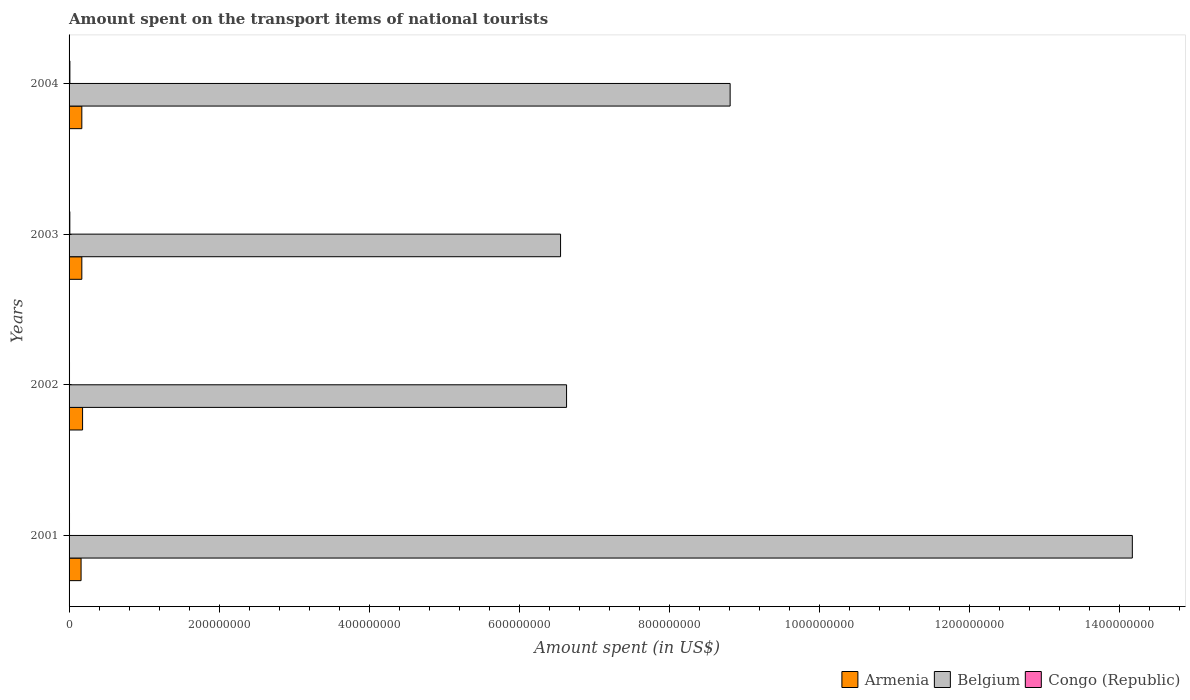How many groups of bars are there?
Your response must be concise. 4. How many bars are there on the 3rd tick from the bottom?
Ensure brevity in your answer.  3. In how many cases, is the number of bars for a given year not equal to the number of legend labels?
Offer a very short reply. 0. What is the amount spent on the transport items of national tourists in Belgium in 2003?
Give a very brief answer. 6.55e+08. Across all years, what is the maximum amount spent on the transport items of national tourists in Congo (Republic)?
Keep it short and to the point. 1.10e+06. What is the total amount spent on the transport items of national tourists in Congo (Republic) in the graph?
Provide a short and direct response. 3.30e+06. What is the difference between the amount spent on the transport items of national tourists in Belgium in 2004 and the amount spent on the transport items of national tourists in Armenia in 2002?
Your answer should be compact. 8.63e+08. What is the average amount spent on the transport items of national tourists in Belgium per year?
Offer a very short reply. 9.04e+08. In the year 2004, what is the difference between the amount spent on the transport items of national tourists in Congo (Republic) and amount spent on the transport items of national tourists in Belgium?
Provide a short and direct response. -8.80e+08. What is the ratio of the amount spent on the transport items of national tourists in Belgium in 2001 to that in 2003?
Make the answer very short. 2.16. Is the difference between the amount spent on the transport items of national tourists in Congo (Republic) in 2001 and 2003 greater than the difference between the amount spent on the transport items of national tourists in Belgium in 2001 and 2003?
Provide a short and direct response. No. What is the difference between the highest and the second highest amount spent on the transport items of national tourists in Belgium?
Your answer should be compact. 5.36e+08. What is the difference between the highest and the lowest amount spent on the transport items of national tourists in Belgium?
Make the answer very short. 7.62e+08. What does the 2nd bar from the top in 2003 represents?
Your response must be concise. Belgium. What does the 1st bar from the bottom in 2002 represents?
Give a very brief answer. Armenia. How many bars are there?
Provide a short and direct response. 12. Are all the bars in the graph horizontal?
Keep it short and to the point. Yes. Are the values on the major ticks of X-axis written in scientific E-notation?
Your answer should be very brief. No. Where does the legend appear in the graph?
Provide a succinct answer. Bottom right. What is the title of the graph?
Ensure brevity in your answer.  Amount spent on the transport items of national tourists. Does "Syrian Arab Republic" appear as one of the legend labels in the graph?
Provide a succinct answer. No. What is the label or title of the X-axis?
Your response must be concise. Amount spent (in US$). What is the Amount spent (in US$) of Armenia in 2001?
Provide a short and direct response. 1.60e+07. What is the Amount spent (in US$) in Belgium in 2001?
Offer a very short reply. 1.42e+09. What is the Amount spent (in US$) in Armenia in 2002?
Provide a short and direct response. 1.80e+07. What is the Amount spent (in US$) in Belgium in 2002?
Your answer should be compact. 6.63e+08. What is the Amount spent (in US$) of Armenia in 2003?
Offer a terse response. 1.70e+07. What is the Amount spent (in US$) in Belgium in 2003?
Your answer should be compact. 6.55e+08. What is the Amount spent (in US$) of Armenia in 2004?
Make the answer very short. 1.70e+07. What is the Amount spent (in US$) in Belgium in 2004?
Your response must be concise. 8.81e+08. What is the Amount spent (in US$) of Congo (Republic) in 2004?
Provide a succinct answer. 1.10e+06. Across all years, what is the maximum Amount spent (in US$) of Armenia?
Offer a very short reply. 1.80e+07. Across all years, what is the maximum Amount spent (in US$) of Belgium?
Your answer should be compact. 1.42e+09. Across all years, what is the maximum Amount spent (in US$) in Congo (Republic)?
Give a very brief answer. 1.10e+06. Across all years, what is the minimum Amount spent (in US$) of Armenia?
Give a very brief answer. 1.60e+07. Across all years, what is the minimum Amount spent (in US$) of Belgium?
Ensure brevity in your answer.  6.55e+08. Across all years, what is the minimum Amount spent (in US$) in Congo (Republic)?
Provide a succinct answer. 6.00e+05. What is the total Amount spent (in US$) in Armenia in the graph?
Give a very brief answer. 6.80e+07. What is the total Amount spent (in US$) in Belgium in the graph?
Provide a succinct answer. 3.62e+09. What is the total Amount spent (in US$) of Congo (Republic) in the graph?
Provide a short and direct response. 3.30e+06. What is the difference between the Amount spent (in US$) of Belgium in 2001 and that in 2002?
Offer a very short reply. 7.54e+08. What is the difference between the Amount spent (in US$) in Belgium in 2001 and that in 2003?
Your answer should be compact. 7.62e+08. What is the difference between the Amount spent (in US$) of Congo (Republic) in 2001 and that in 2003?
Ensure brevity in your answer.  -4.00e+05. What is the difference between the Amount spent (in US$) of Armenia in 2001 and that in 2004?
Provide a succinct answer. -1.00e+06. What is the difference between the Amount spent (in US$) of Belgium in 2001 and that in 2004?
Ensure brevity in your answer.  5.36e+08. What is the difference between the Amount spent (in US$) in Congo (Republic) in 2001 and that in 2004?
Your answer should be compact. -5.00e+05. What is the difference between the Amount spent (in US$) in Armenia in 2002 and that in 2003?
Offer a terse response. 1.00e+06. What is the difference between the Amount spent (in US$) in Belgium in 2002 and that in 2003?
Ensure brevity in your answer.  8.00e+06. What is the difference between the Amount spent (in US$) in Congo (Republic) in 2002 and that in 2003?
Your answer should be very brief. -4.00e+05. What is the difference between the Amount spent (in US$) of Belgium in 2002 and that in 2004?
Your answer should be compact. -2.18e+08. What is the difference between the Amount spent (in US$) in Congo (Republic) in 2002 and that in 2004?
Your answer should be very brief. -5.00e+05. What is the difference between the Amount spent (in US$) of Belgium in 2003 and that in 2004?
Your answer should be very brief. -2.26e+08. What is the difference between the Amount spent (in US$) of Congo (Republic) in 2003 and that in 2004?
Your answer should be compact. -1.00e+05. What is the difference between the Amount spent (in US$) in Armenia in 2001 and the Amount spent (in US$) in Belgium in 2002?
Keep it short and to the point. -6.47e+08. What is the difference between the Amount spent (in US$) of Armenia in 2001 and the Amount spent (in US$) of Congo (Republic) in 2002?
Ensure brevity in your answer.  1.54e+07. What is the difference between the Amount spent (in US$) in Belgium in 2001 and the Amount spent (in US$) in Congo (Republic) in 2002?
Offer a terse response. 1.42e+09. What is the difference between the Amount spent (in US$) in Armenia in 2001 and the Amount spent (in US$) in Belgium in 2003?
Your response must be concise. -6.39e+08. What is the difference between the Amount spent (in US$) in Armenia in 2001 and the Amount spent (in US$) in Congo (Republic) in 2003?
Ensure brevity in your answer.  1.50e+07. What is the difference between the Amount spent (in US$) of Belgium in 2001 and the Amount spent (in US$) of Congo (Republic) in 2003?
Offer a very short reply. 1.42e+09. What is the difference between the Amount spent (in US$) of Armenia in 2001 and the Amount spent (in US$) of Belgium in 2004?
Provide a succinct answer. -8.65e+08. What is the difference between the Amount spent (in US$) in Armenia in 2001 and the Amount spent (in US$) in Congo (Republic) in 2004?
Your response must be concise. 1.49e+07. What is the difference between the Amount spent (in US$) in Belgium in 2001 and the Amount spent (in US$) in Congo (Republic) in 2004?
Make the answer very short. 1.42e+09. What is the difference between the Amount spent (in US$) in Armenia in 2002 and the Amount spent (in US$) in Belgium in 2003?
Make the answer very short. -6.37e+08. What is the difference between the Amount spent (in US$) in Armenia in 2002 and the Amount spent (in US$) in Congo (Republic) in 2003?
Ensure brevity in your answer.  1.70e+07. What is the difference between the Amount spent (in US$) in Belgium in 2002 and the Amount spent (in US$) in Congo (Republic) in 2003?
Your answer should be compact. 6.62e+08. What is the difference between the Amount spent (in US$) of Armenia in 2002 and the Amount spent (in US$) of Belgium in 2004?
Provide a short and direct response. -8.63e+08. What is the difference between the Amount spent (in US$) of Armenia in 2002 and the Amount spent (in US$) of Congo (Republic) in 2004?
Provide a succinct answer. 1.69e+07. What is the difference between the Amount spent (in US$) of Belgium in 2002 and the Amount spent (in US$) of Congo (Republic) in 2004?
Make the answer very short. 6.62e+08. What is the difference between the Amount spent (in US$) of Armenia in 2003 and the Amount spent (in US$) of Belgium in 2004?
Your answer should be very brief. -8.64e+08. What is the difference between the Amount spent (in US$) of Armenia in 2003 and the Amount spent (in US$) of Congo (Republic) in 2004?
Keep it short and to the point. 1.59e+07. What is the difference between the Amount spent (in US$) of Belgium in 2003 and the Amount spent (in US$) of Congo (Republic) in 2004?
Give a very brief answer. 6.54e+08. What is the average Amount spent (in US$) of Armenia per year?
Your response must be concise. 1.70e+07. What is the average Amount spent (in US$) of Belgium per year?
Make the answer very short. 9.04e+08. What is the average Amount spent (in US$) of Congo (Republic) per year?
Offer a very short reply. 8.25e+05. In the year 2001, what is the difference between the Amount spent (in US$) of Armenia and Amount spent (in US$) of Belgium?
Your answer should be compact. -1.40e+09. In the year 2001, what is the difference between the Amount spent (in US$) of Armenia and Amount spent (in US$) of Congo (Republic)?
Ensure brevity in your answer.  1.54e+07. In the year 2001, what is the difference between the Amount spent (in US$) in Belgium and Amount spent (in US$) in Congo (Republic)?
Your answer should be compact. 1.42e+09. In the year 2002, what is the difference between the Amount spent (in US$) of Armenia and Amount spent (in US$) of Belgium?
Offer a very short reply. -6.45e+08. In the year 2002, what is the difference between the Amount spent (in US$) of Armenia and Amount spent (in US$) of Congo (Republic)?
Your response must be concise. 1.74e+07. In the year 2002, what is the difference between the Amount spent (in US$) in Belgium and Amount spent (in US$) in Congo (Republic)?
Give a very brief answer. 6.62e+08. In the year 2003, what is the difference between the Amount spent (in US$) in Armenia and Amount spent (in US$) in Belgium?
Your answer should be compact. -6.38e+08. In the year 2003, what is the difference between the Amount spent (in US$) of Armenia and Amount spent (in US$) of Congo (Republic)?
Your response must be concise. 1.60e+07. In the year 2003, what is the difference between the Amount spent (in US$) of Belgium and Amount spent (in US$) of Congo (Republic)?
Make the answer very short. 6.54e+08. In the year 2004, what is the difference between the Amount spent (in US$) of Armenia and Amount spent (in US$) of Belgium?
Ensure brevity in your answer.  -8.64e+08. In the year 2004, what is the difference between the Amount spent (in US$) of Armenia and Amount spent (in US$) of Congo (Republic)?
Ensure brevity in your answer.  1.59e+07. In the year 2004, what is the difference between the Amount spent (in US$) of Belgium and Amount spent (in US$) of Congo (Republic)?
Offer a very short reply. 8.80e+08. What is the ratio of the Amount spent (in US$) in Belgium in 2001 to that in 2002?
Ensure brevity in your answer.  2.14. What is the ratio of the Amount spent (in US$) in Armenia in 2001 to that in 2003?
Give a very brief answer. 0.94. What is the ratio of the Amount spent (in US$) of Belgium in 2001 to that in 2003?
Keep it short and to the point. 2.16. What is the ratio of the Amount spent (in US$) of Congo (Republic) in 2001 to that in 2003?
Your answer should be compact. 0.6. What is the ratio of the Amount spent (in US$) of Armenia in 2001 to that in 2004?
Provide a short and direct response. 0.94. What is the ratio of the Amount spent (in US$) in Belgium in 2001 to that in 2004?
Your answer should be very brief. 1.61. What is the ratio of the Amount spent (in US$) in Congo (Republic) in 2001 to that in 2004?
Offer a very short reply. 0.55. What is the ratio of the Amount spent (in US$) in Armenia in 2002 to that in 2003?
Keep it short and to the point. 1.06. What is the ratio of the Amount spent (in US$) in Belgium in 2002 to that in 2003?
Keep it short and to the point. 1.01. What is the ratio of the Amount spent (in US$) in Armenia in 2002 to that in 2004?
Give a very brief answer. 1.06. What is the ratio of the Amount spent (in US$) of Belgium in 2002 to that in 2004?
Offer a very short reply. 0.75. What is the ratio of the Amount spent (in US$) of Congo (Republic) in 2002 to that in 2004?
Offer a very short reply. 0.55. What is the ratio of the Amount spent (in US$) in Armenia in 2003 to that in 2004?
Your answer should be compact. 1. What is the ratio of the Amount spent (in US$) in Belgium in 2003 to that in 2004?
Offer a very short reply. 0.74. What is the ratio of the Amount spent (in US$) of Congo (Republic) in 2003 to that in 2004?
Your response must be concise. 0.91. What is the difference between the highest and the second highest Amount spent (in US$) in Belgium?
Your answer should be compact. 5.36e+08. What is the difference between the highest and the second highest Amount spent (in US$) of Congo (Republic)?
Provide a succinct answer. 1.00e+05. What is the difference between the highest and the lowest Amount spent (in US$) in Armenia?
Give a very brief answer. 2.00e+06. What is the difference between the highest and the lowest Amount spent (in US$) of Belgium?
Your answer should be very brief. 7.62e+08. What is the difference between the highest and the lowest Amount spent (in US$) of Congo (Republic)?
Provide a short and direct response. 5.00e+05. 